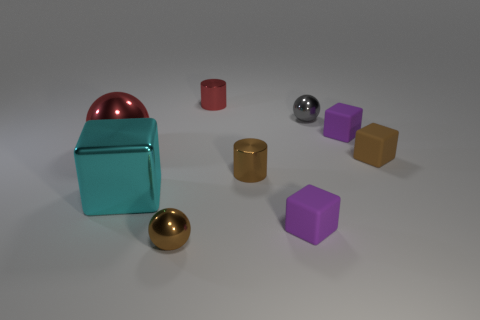The red object that is the same size as the brown sphere is what shape?
Ensure brevity in your answer.  Cylinder. Are there any small things of the same color as the big sphere?
Your answer should be very brief. Yes. The cyan metallic block has what size?
Provide a succinct answer. Large. Do the large cyan thing and the small brown block have the same material?
Your response must be concise. No. There is a small brown metal object behind the ball in front of the cyan metallic object; what number of small metal balls are behind it?
Your answer should be very brief. 1. There is a large thing that is in front of the tiny brown cube; what is its shape?
Offer a terse response. Cube. How many other objects are there of the same material as the tiny brown ball?
Offer a terse response. 5. Is the number of tiny metallic things that are left of the tiny red cylinder less than the number of large objects that are behind the small brown shiny ball?
Keep it short and to the point. Yes. What is the color of the other big thing that is the same shape as the gray object?
Provide a short and direct response. Red. There is a brown shiny object that is behind the brown shiny sphere; does it have the same size as the cyan block?
Provide a short and direct response. No. 